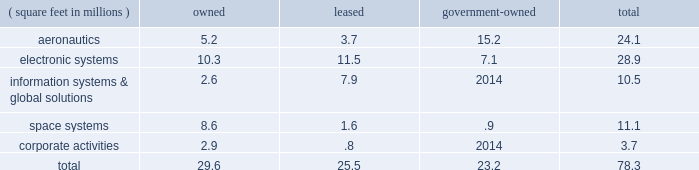The following is a summary of our floor space by business segment at december 31 , 2010 : ( square feet in millions ) owned leased government- owned total .
Some of our owned properties , primarily classified under corporate activities , are leased to third parties .
In the area of manufacturing , most of the operations are of a job-order nature , rather than an assembly line process , and productive equipment has multiple uses for multiple products .
Management believes that all of our major physical facilities are in good condition and are adequate for their intended use .
Item 3 .
Legal proceedings we are a party to or have property subject to litigation and other proceedings , including matters arising under provisions relating to the protection of the environment .
We believe the probability is remote that the outcome of these matters will have a material adverse effect on the corporation as a whole , notwithstanding that the unfavorable resolution of any matter may have a material effect on our net earnings in any particular quarter .
We cannot predict the outcome of legal proceedings with certainty .
These matters include the proceedings summarized in note 14 2013 legal proceedings , commitments , and contingencies beginning on page 78 of this form 10-k .
From time-to-time , agencies of the u.s .
Government investigate whether our operations are being conducted in accordance with applicable regulatory requirements .
U.s .
Government investigations of us , whether relating to government contracts or conducted for other reasons , could result in administrative , civil , or criminal liabilities , including repayments , fines , or penalties being imposed upon us , or could lead to suspension or debarment from future u.s .
Government contracting .
U.s .
Government investigations often take years to complete and many result in no adverse action against us .
We are subject to federal and state requirements for protection of the environment , including those for discharge of hazardous materials and remediation of contaminated sites .
As a result , we are a party to or have our property subject to various lawsuits or proceedings involving environmental protection matters .
Due in part to their complexity and pervasiveness , such requirements have resulted in us being involved with related legal proceedings , claims , and remediation obligations .
The extent of our financial exposure cannot in all cases be reasonably estimated at this time .
For information regarding these matters , including current estimates of the amounts that we believe are required for remediation or clean-up to the extent estimable , see 201ccritical accounting policies 2013 environmental matters 201d in management 2019s discussion and analysis of financial condition and results of operations beginning on page 45 , and note 14 2013 legal proceedings , commitments , and contingencies beginning on page 78 of this form 10-k .
Item 4 .
( removed and reserved ) item 4 ( a ) .
Executive officers of the registrant our executive officers are listed below , as well as information concerning their age at december 31 , 2010 , positions and offices held with the corporation , and principal occupation and business experience over the past five years .
There were no family relationships among any of our executive officers and directors .
All officers serve at the pleasure of the board of directors .
Linda r .
Gooden ( 57 ) , executive vice president 2013 information systems & global solutions ms .
Gooden has served as executive vice president 2013 information systems & global solutions since january 2007 .
She previously served as deputy executive vice president 2013 information & technology services from october 2006 to december 2006 , and president , lockheed martin information technology from september 1997 to december 2006 .
Christopher j .
Gregoire ( 42 ) , vice president and controller ( chief accounting officer ) mr .
Gregoire has served as vice president and controller ( chief accounting officer ) since march 2010 .
He previously was employed by sprint nextel corporation from august 2006 to may 2009 , most recently as principal accounting officer and assistant controller , and was a partner at deloitte & touche llp from september 2003 to july 2006. .
What percentage of total floor space by business segment at december 31 , 2010 is owned? 
Computations: (29.6 / 78.3)
Answer: 0.37803. 